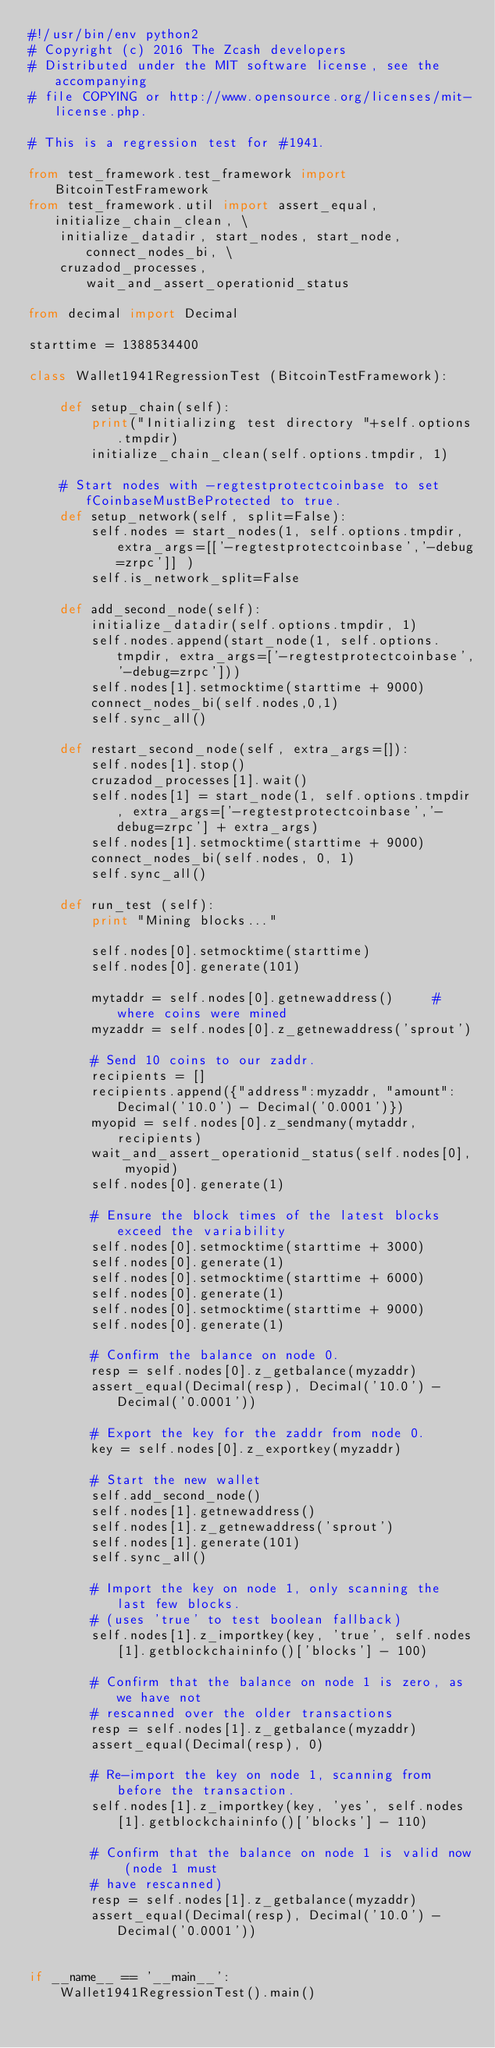<code> <loc_0><loc_0><loc_500><loc_500><_Python_>#!/usr/bin/env python2
# Copyright (c) 2016 The Zcash developers
# Distributed under the MIT software license, see the accompanying
# file COPYING or http://www.opensource.org/licenses/mit-license.php.

# This is a regression test for #1941.

from test_framework.test_framework import BitcoinTestFramework
from test_framework.util import assert_equal, initialize_chain_clean, \
    initialize_datadir, start_nodes, start_node, connect_nodes_bi, \
    cruzadod_processes, wait_and_assert_operationid_status

from decimal import Decimal

starttime = 1388534400

class Wallet1941RegressionTest (BitcoinTestFramework):

    def setup_chain(self):
        print("Initializing test directory "+self.options.tmpdir)
        initialize_chain_clean(self.options.tmpdir, 1)

    # Start nodes with -regtestprotectcoinbase to set fCoinbaseMustBeProtected to true.
    def setup_network(self, split=False):
        self.nodes = start_nodes(1, self.options.tmpdir, extra_args=[['-regtestprotectcoinbase','-debug=zrpc']] )
        self.is_network_split=False

    def add_second_node(self):
        initialize_datadir(self.options.tmpdir, 1)
        self.nodes.append(start_node(1, self.options.tmpdir, extra_args=['-regtestprotectcoinbase','-debug=zrpc']))
        self.nodes[1].setmocktime(starttime + 9000)
        connect_nodes_bi(self.nodes,0,1)
        self.sync_all()

    def restart_second_node(self, extra_args=[]):
        self.nodes[1].stop()
        cruzadod_processes[1].wait()
        self.nodes[1] = start_node(1, self.options.tmpdir, extra_args=['-regtestprotectcoinbase','-debug=zrpc'] + extra_args)
        self.nodes[1].setmocktime(starttime + 9000)
        connect_nodes_bi(self.nodes, 0, 1)
        self.sync_all()

    def run_test (self):
        print "Mining blocks..."

        self.nodes[0].setmocktime(starttime)
        self.nodes[0].generate(101)

        mytaddr = self.nodes[0].getnewaddress()     # where coins were mined
        myzaddr = self.nodes[0].z_getnewaddress('sprout')

        # Send 10 coins to our zaddr.
        recipients = []
        recipients.append({"address":myzaddr, "amount":Decimal('10.0') - Decimal('0.0001')})
        myopid = self.nodes[0].z_sendmany(mytaddr, recipients)
        wait_and_assert_operationid_status(self.nodes[0], myopid)
        self.nodes[0].generate(1)

        # Ensure the block times of the latest blocks exceed the variability
        self.nodes[0].setmocktime(starttime + 3000)
        self.nodes[0].generate(1)
        self.nodes[0].setmocktime(starttime + 6000)
        self.nodes[0].generate(1)
        self.nodes[0].setmocktime(starttime + 9000)
        self.nodes[0].generate(1)

        # Confirm the balance on node 0.
        resp = self.nodes[0].z_getbalance(myzaddr)
        assert_equal(Decimal(resp), Decimal('10.0') - Decimal('0.0001'))

        # Export the key for the zaddr from node 0.
        key = self.nodes[0].z_exportkey(myzaddr)

        # Start the new wallet
        self.add_second_node()
        self.nodes[1].getnewaddress()
        self.nodes[1].z_getnewaddress('sprout')
        self.nodes[1].generate(101)
        self.sync_all()

        # Import the key on node 1, only scanning the last few blocks.
        # (uses 'true' to test boolean fallback)
        self.nodes[1].z_importkey(key, 'true', self.nodes[1].getblockchaininfo()['blocks'] - 100)

        # Confirm that the balance on node 1 is zero, as we have not
        # rescanned over the older transactions
        resp = self.nodes[1].z_getbalance(myzaddr)
        assert_equal(Decimal(resp), 0)

        # Re-import the key on node 1, scanning from before the transaction.
        self.nodes[1].z_importkey(key, 'yes', self.nodes[1].getblockchaininfo()['blocks'] - 110)

        # Confirm that the balance on node 1 is valid now (node 1 must
        # have rescanned)
        resp = self.nodes[1].z_getbalance(myzaddr)
        assert_equal(Decimal(resp), Decimal('10.0') - Decimal('0.0001'))


if __name__ == '__main__':
    Wallet1941RegressionTest().main()
</code> 